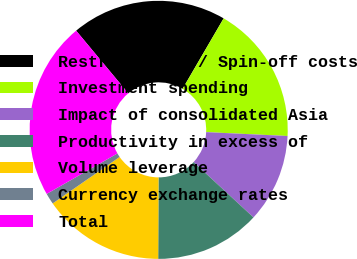Convert chart to OTSL. <chart><loc_0><loc_0><loc_500><loc_500><pie_chart><fcel>Restructuring / Spin-off costs<fcel>Investment spending<fcel>Impact of consolidated Asia<fcel>Productivity in excess of<fcel>Volume leverage<fcel>Currency exchange rates<fcel>Total<nl><fcel>19.44%<fcel>17.36%<fcel>11.11%<fcel>13.19%<fcel>15.28%<fcel>1.39%<fcel>22.22%<nl></chart> 